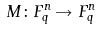<formula> <loc_0><loc_0><loc_500><loc_500>M \colon F _ { q } ^ { n } \rightarrow F _ { q } ^ { n }</formula> 